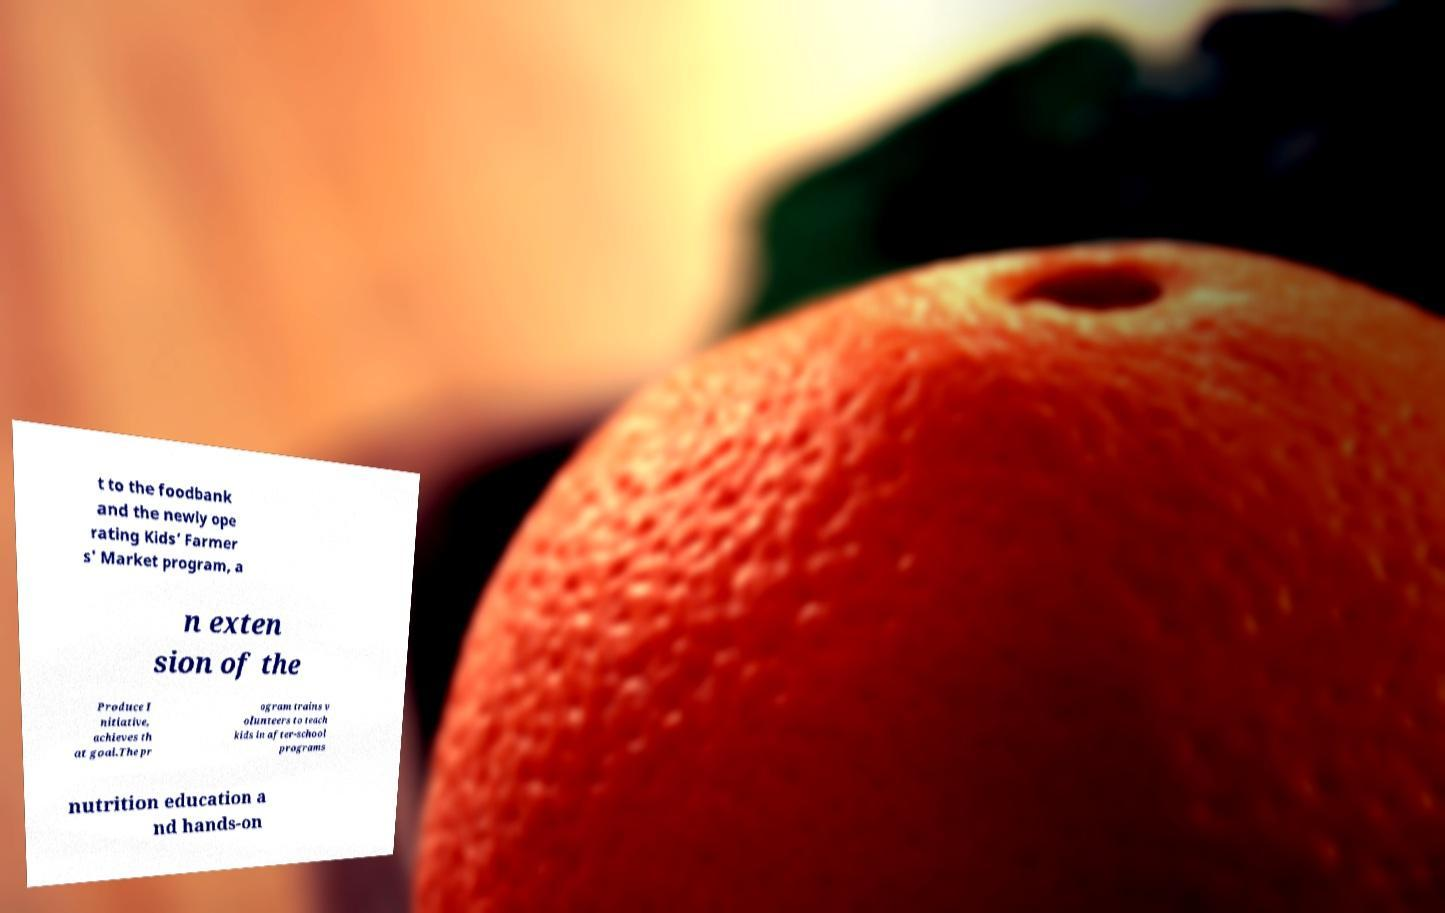Could you extract and type out the text from this image? t to the foodbank and the newly ope rating Kids’ Farmer s' Market program, a n exten sion of the Produce I nitiative, achieves th at goal.The pr ogram trains v olunteers to teach kids in after-school programs nutrition education a nd hands-on 